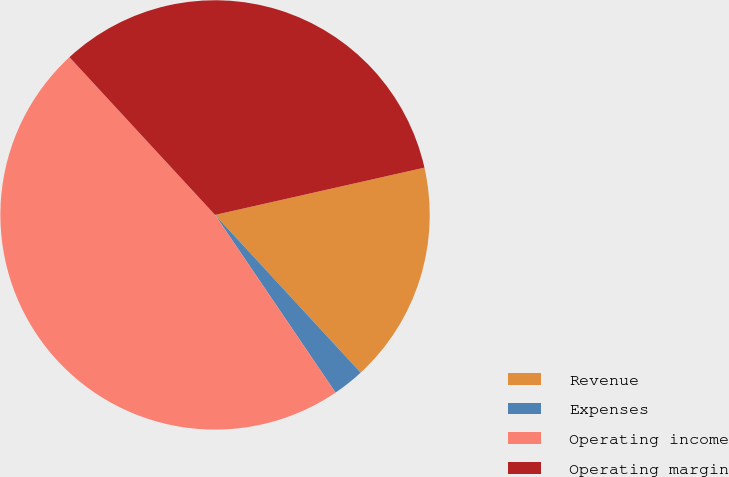<chart> <loc_0><loc_0><loc_500><loc_500><pie_chart><fcel>Revenue<fcel>Expenses<fcel>Operating income<fcel>Operating margin<nl><fcel>16.67%<fcel>2.38%<fcel>47.62%<fcel>33.33%<nl></chart> 